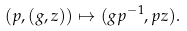<formula> <loc_0><loc_0><loc_500><loc_500>( p , ( g , z ) ) \mapsto ( g p ^ { - 1 } , p z ) .</formula> 